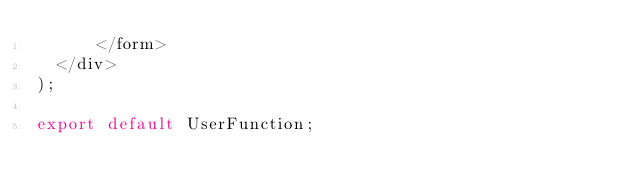Convert code to text. <code><loc_0><loc_0><loc_500><loc_500><_JavaScript_>      </form>
  </div>
);

export default UserFunction;

</code> 